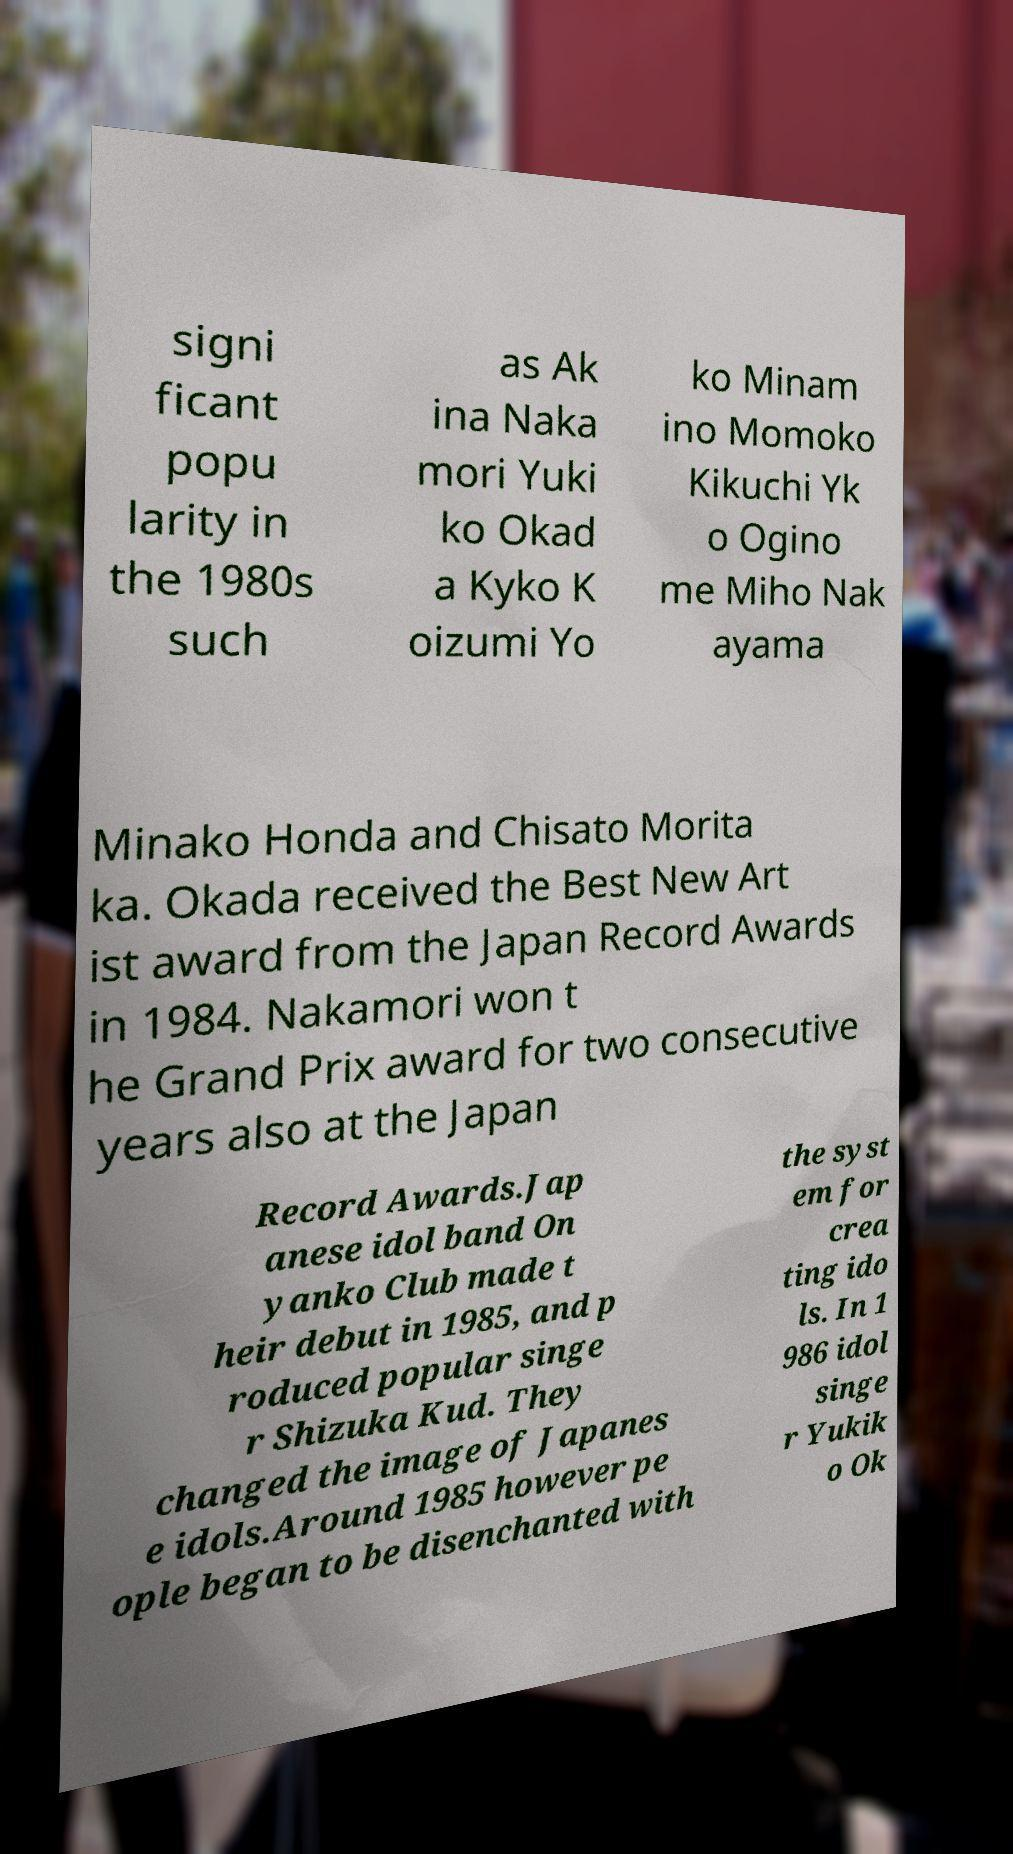For documentation purposes, I need the text within this image transcribed. Could you provide that? signi ficant popu larity in the 1980s such as Ak ina Naka mori Yuki ko Okad a Kyko K oizumi Yo ko Minam ino Momoko Kikuchi Yk o Ogino me Miho Nak ayama Minako Honda and Chisato Morita ka. Okada received the Best New Art ist award from the Japan Record Awards in 1984. Nakamori won t he Grand Prix award for two consecutive years also at the Japan Record Awards.Jap anese idol band On yanko Club made t heir debut in 1985, and p roduced popular singe r Shizuka Kud. They changed the image of Japanes e idols.Around 1985 however pe ople began to be disenchanted with the syst em for crea ting ido ls. In 1 986 idol singe r Yukik o Ok 